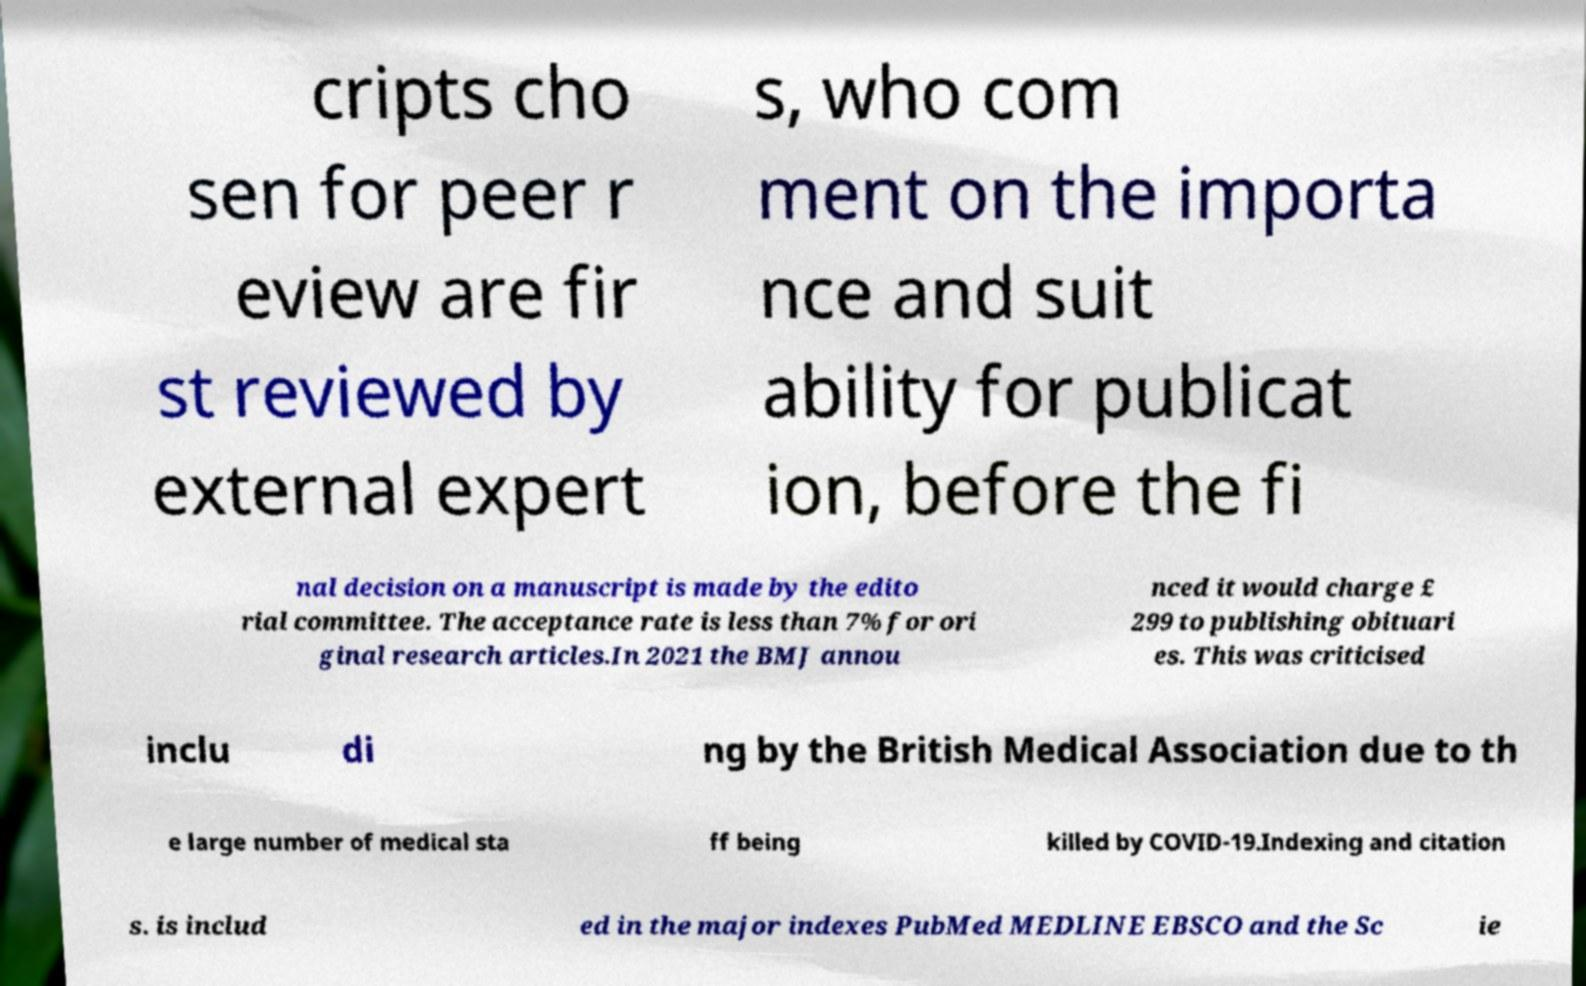Can you accurately transcribe the text from the provided image for me? cripts cho sen for peer r eview are fir st reviewed by external expert s, who com ment on the importa nce and suit ability for publicat ion, before the fi nal decision on a manuscript is made by the edito rial committee. The acceptance rate is less than 7% for ori ginal research articles.In 2021 the BMJ annou nced it would charge £ 299 to publishing obituari es. This was criticised inclu di ng by the British Medical Association due to th e large number of medical sta ff being killed by COVID-19.Indexing and citation s. is includ ed in the major indexes PubMed MEDLINE EBSCO and the Sc ie 